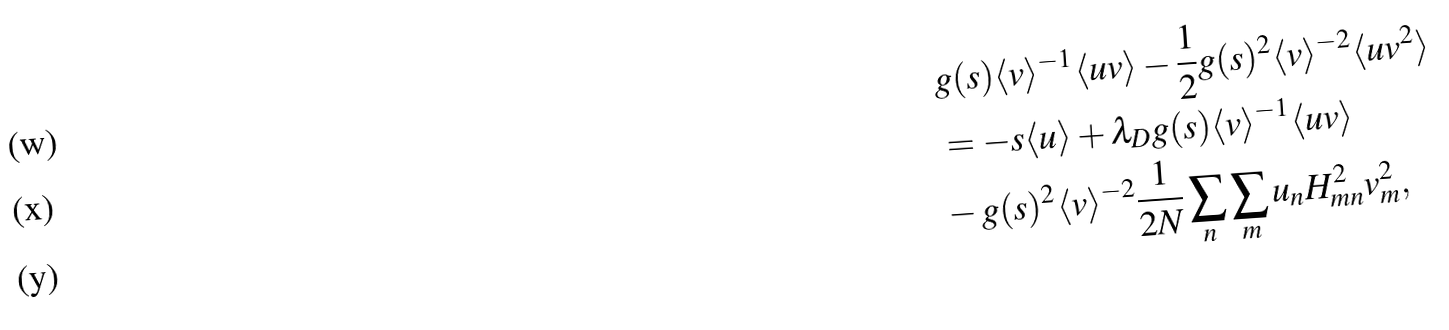<formula> <loc_0><loc_0><loc_500><loc_500>& g ( s ) \langle v \rangle ^ { - 1 } \langle u v \rangle - \frac { 1 } { 2 } g ( s ) ^ { 2 } \langle v \rangle ^ { - 2 } \langle u v ^ { 2 } \rangle \\ & = - s \langle u \rangle + \lambda _ { D } g ( s ) \langle v \rangle ^ { - 1 } \langle u v \rangle \\ & - g ( s ) ^ { 2 } \langle v \rangle ^ { - 2 } \frac { 1 } { 2 N } \sum _ { n } \sum _ { m } u _ { n } H _ { m n } ^ { 2 } v _ { m } ^ { 2 } ,</formula> 